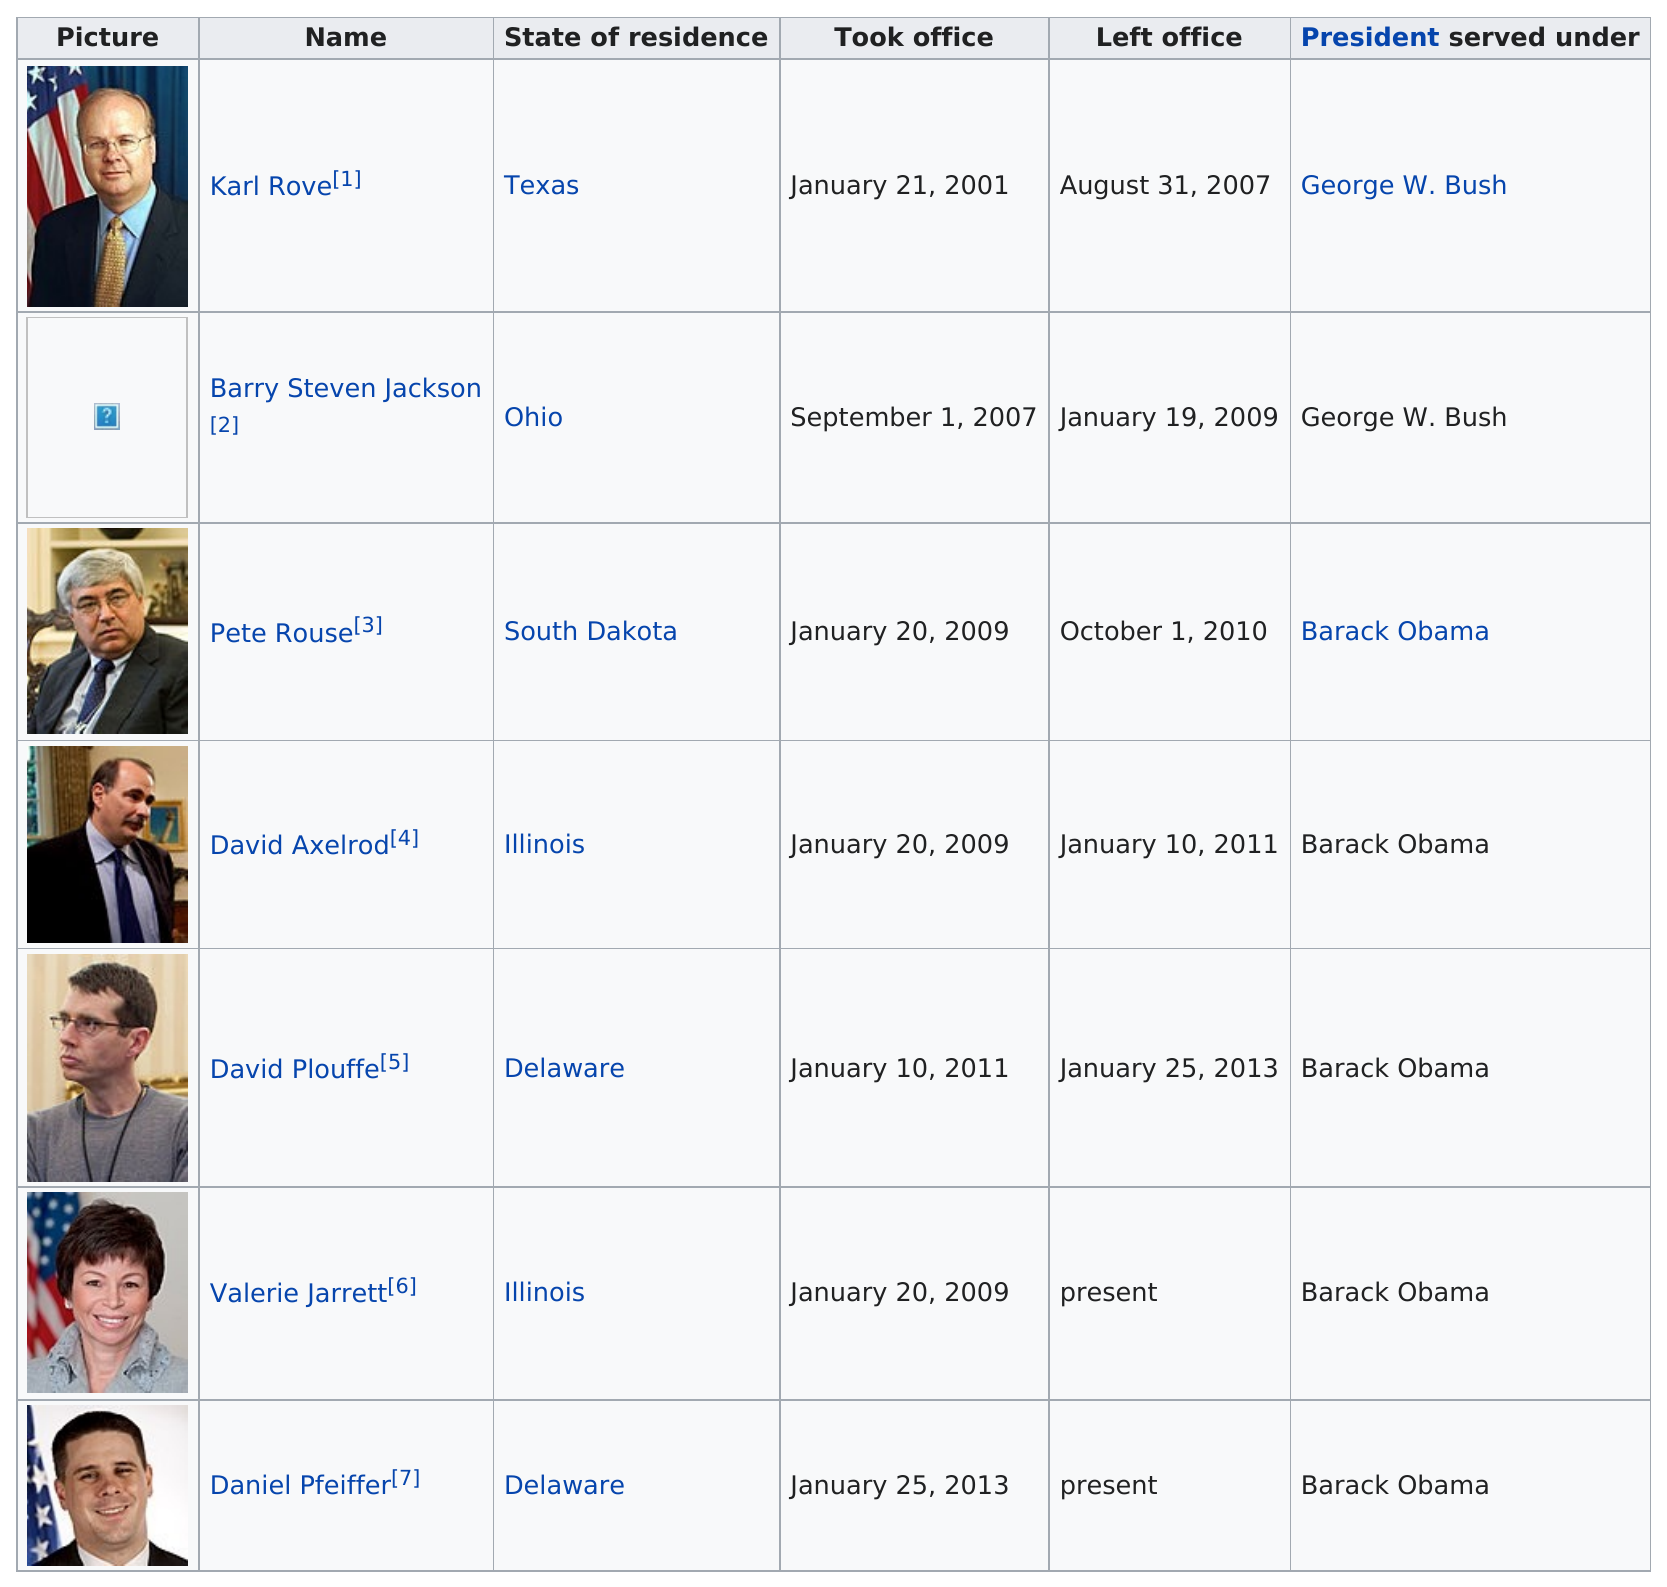Identify some key points in this picture. Barry Steven Jackson was an advisor who served under the same president as Karl Rove. Valerie Jarrett is the only woman who has served as a senior advisor. Karl Rove served in office for a total of 6 years. There have been a total of 7 senior advisors. Karl Rove, a senior advisor, has served in his position for at least four years. 